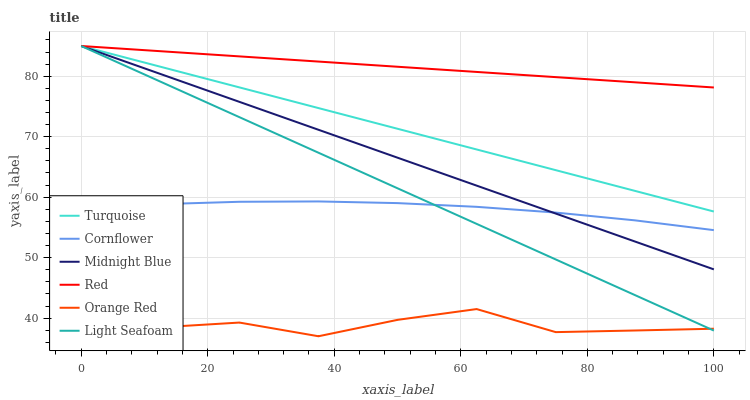Does Orange Red have the minimum area under the curve?
Answer yes or no. Yes. Does Red have the maximum area under the curve?
Answer yes or no. Yes. Does Turquoise have the minimum area under the curve?
Answer yes or no. No. Does Turquoise have the maximum area under the curve?
Answer yes or no. No. Is Turquoise the smoothest?
Answer yes or no. Yes. Is Orange Red the roughest?
Answer yes or no. Yes. Is Midnight Blue the smoothest?
Answer yes or no. No. Is Midnight Blue the roughest?
Answer yes or no. No. Does Orange Red have the lowest value?
Answer yes or no. Yes. Does Turquoise have the lowest value?
Answer yes or no. No. Does Red have the highest value?
Answer yes or no. Yes. Does Orange Red have the highest value?
Answer yes or no. No. Is Cornflower less than Red?
Answer yes or no. Yes. Is Turquoise greater than Orange Red?
Answer yes or no. Yes. Does Midnight Blue intersect Turquoise?
Answer yes or no. Yes. Is Midnight Blue less than Turquoise?
Answer yes or no. No. Is Midnight Blue greater than Turquoise?
Answer yes or no. No. Does Cornflower intersect Red?
Answer yes or no. No. 